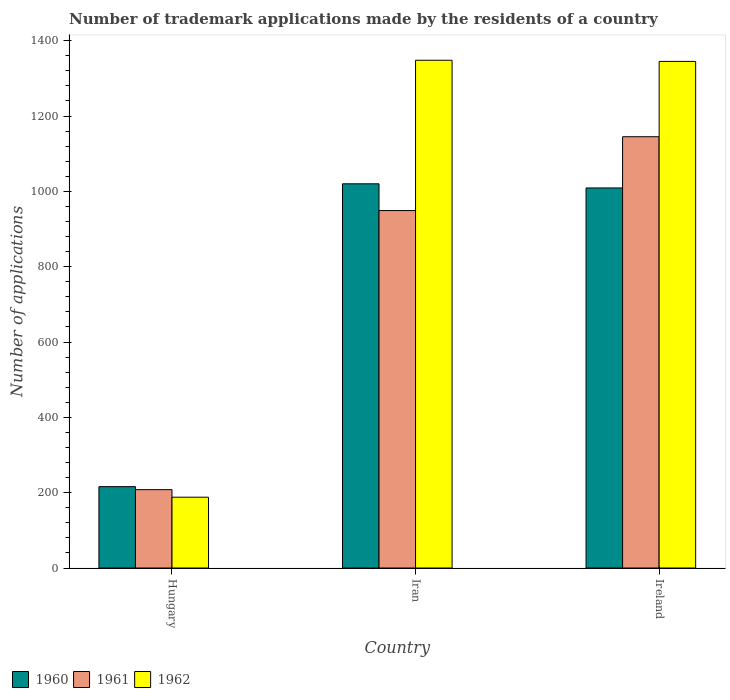How many different coloured bars are there?
Offer a terse response. 3. How many groups of bars are there?
Provide a succinct answer. 3. Are the number of bars on each tick of the X-axis equal?
Give a very brief answer. Yes. How many bars are there on the 1st tick from the left?
Provide a succinct answer. 3. How many bars are there on the 3rd tick from the right?
Provide a short and direct response. 3. What is the label of the 2nd group of bars from the left?
Your answer should be very brief. Iran. What is the number of trademark applications made by the residents in 1961 in Ireland?
Keep it short and to the point. 1145. Across all countries, what is the maximum number of trademark applications made by the residents in 1962?
Make the answer very short. 1348. Across all countries, what is the minimum number of trademark applications made by the residents in 1961?
Make the answer very short. 208. In which country was the number of trademark applications made by the residents in 1961 maximum?
Keep it short and to the point. Ireland. In which country was the number of trademark applications made by the residents in 1961 minimum?
Ensure brevity in your answer.  Hungary. What is the total number of trademark applications made by the residents in 1961 in the graph?
Offer a terse response. 2302. What is the difference between the number of trademark applications made by the residents in 1961 in Iran and that in Ireland?
Provide a short and direct response. -196. What is the difference between the number of trademark applications made by the residents in 1962 in Hungary and the number of trademark applications made by the residents in 1960 in Iran?
Your response must be concise. -832. What is the average number of trademark applications made by the residents in 1962 per country?
Provide a short and direct response. 960.33. In how many countries, is the number of trademark applications made by the residents in 1960 greater than 960?
Ensure brevity in your answer.  2. What is the ratio of the number of trademark applications made by the residents in 1962 in Hungary to that in Ireland?
Your answer should be compact. 0.14. Is the number of trademark applications made by the residents in 1960 in Iran less than that in Ireland?
Offer a very short reply. No. Is the difference between the number of trademark applications made by the residents in 1960 in Iran and Ireland greater than the difference between the number of trademark applications made by the residents in 1961 in Iran and Ireland?
Ensure brevity in your answer.  Yes. What is the difference between the highest and the second highest number of trademark applications made by the residents in 1962?
Offer a very short reply. 1157. What is the difference between the highest and the lowest number of trademark applications made by the residents in 1962?
Your answer should be compact. 1160. In how many countries, is the number of trademark applications made by the residents in 1960 greater than the average number of trademark applications made by the residents in 1960 taken over all countries?
Keep it short and to the point. 2. What does the 2nd bar from the left in Iran represents?
Your answer should be very brief. 1961. How many bars are there?
Your answer should be compact. 9. Are all the bars in the graph horizontal?
Keep it short and to the point. No. How many countries are there in the graph?
Your answer should be compact. 3. What is the difference between two consecutive major ticks on the Y-axis?
Your response must be concise. 200. Are the values on the major ticks of Y-axis written in scientific E-notation?
Your answer should be compact. No. Does the graph contain grids?
Ensure brevity in your answer.  No. Where does the legend appear in the graph?
Your answer should be very brief. Bottom left. How are the legend labels stacked?
Keep it short and to the point. Horizontal. What is the title of the graph?
Offer a terse response. Number of trademark applications made by the residents of a country. What is the label or title of the Y-axis?
Offer a terse response. Number of applications. What is the Number of applications of 1960 in Hungary?
Offer a terse response. 216. What is the Number of applications of 1961 in Hungary?
Your answer should be compact. 208. What is the Number of applications of 1962 in Hungary?
Give a very brief answer. 188. What is the Number of applications in 1960 in Iran?
Give a very brief answer. 1020. What is the Number of applications of 1961 in Iran?
Give a very brief answer. 949. What is the Number of applications in 1962 in Iran?
Make the answer very short. 1348. What is the Number of applications of 1960 in Ireland?
Your answer should be compact. 1009. What is the Number of applications in 1961 in Ireland?
Give a very brief answer. 1145. What is the Number of applications in 1962 in Ireland?
Your answer should be compact. 1345. Across all countries, what is the maximum Number of applications of 1960?
Keep it short and to the point. 1020. Across all countries, what is the maximum Number of applications of 1961?
Provide a short and direct response. 1145. Across all countries, what is the maximum Number of applications in 1962?
Provide a succinct answer. 1348. Across all countries, what is the minimum Number of applications of 1960?
Offer a very short reply. 216. Across all countries, what is the minimum Number of applications in 1961?
Offer a terse response. 208. Across all countries, what is the minimum Number of applications in 1962?
Provide a short and direct response. 188. What is the total Number of applications of 1960 in the graph?
Keep it short and to the point. 2245. What is the total Number of applications of 1961 in the graph?
Keep it short and to the point. 2302. What is the total Number of applications of 1962 in the graph?
Your answer should be compact. 2881. What is the difference between the Number of applications of 1960 in Hungary and that in Iran?
Offer a very short reply. -804. What is the difference between the Number of applications of 1961 in Hungary and that in Iran?
Provide a succinct answer. -741. What is the difference between the Number of applications in 1962 in Hungary and that in Iran?
Keep it short and to the point. -1160. What is the difference between the Number of applications in 1960 in Hungary and that in Ireland?
Your answer should be compact. -793. What is the difference between the Number of applications of 1961 in Hungary and that in Ireland?
Provide a short and direct response. -937. What is the difference between the Number of applications in 1962 in Hungary and that in Ireland?
Offer a very short reply. -1157. What is the difference between the Number of applications in 1961 in Iran and that in Ireland?
Your answer should be very brief. -196. What is the difference between the Number of applications in 1962 in Iran and that in Ireland?
Give a very brief answer. 3. What is the difference between the Number of applications of 1960 in Hungary and the Number of applications of 1961 in Iran?
Ensure brevity in your answer.  -733. What is the difference between the Number of applications of 1960 in Hungary and the Number of applications of 1962 in Iran?
Your answer should be very brief. -1132. What is the difference between the Number of applications in 1961 in Hungary and the Number of applications in 1962 in Iran?
Keep it short and to the point. -1140. What is the difference between the Number of applications of 1960 in Hungary and the Number of applications of 1961 in Ireland?
Your response must be concise. -929. What is the difference between the Number of applications of 1960 in Hungary and the Number of applications of 1962 in Ireland?
Your answer should be very brief. -1129. What is the difference between the Number of applications in 1961 in Hungary and the Number of applications in 1962 in Ireland?
Ensure brevity in your answer.  -1137. What is the difference between the Number of applications of 1960 in Iran and the Number of applications of 1961 in Ireland?
Provide a short and direct response. -125. What is the difference between the Number of applications of 1960 in Iran and the Number of applications of 1962 in Ireland?
Your answer should be very brief. -325. What is the difference between the Number of applications of 1961 in Iran and the Number of applications of 1962 in Ireland?
Keep it short and to the point. -396. What is the average Number of applications in 1960 per country?
Your answer should be very brief. 748.33. What is the average Number of applications of 1961 per country?
Give a very brief answer. 767.33. What is the average Number of applications of 1962 per country?
Offer a very short reply. 960.33. What is the difference between the Number of applications of 1961 and Number of applications of 1962 in Hungary?
Ensure brevity in your answer.  20. What is the difference between the Number of applications in 1960 and Number of applications in 1961 in Iran?
Keep it short and to the point. 71. What is the difference between the Number of applications in 1960 and Number of applications in 1962 in Iran?
Keep it short and to the point. -328. What is the difference between the Number of applications of 1961 and Number of applications of 1962 in Iran?
Keep it short and to the point. -399. What is the difference between the Number of applications of 1960 and Number of applications of 1961 in Ireland?
Provide a succinct answer. -136. What is the difference between the Number of applications in 1960 and Number of applications in 1962 in Ireland?
Ensure brevity in your answer.  -336. What is the difference between the Number of applications of 1961 and Number of applications of 1962 in Ireland?
Provide a succinct answer. -200. What is the ratio of the Number of applications of 1960 in Hungary to that in Iran?
Keep it short and to the point. 0.21. What is the ratio of the Number of applications of 1961 in Hungary to that in Iran?
Give a very brief answer. 0.22. What is the ratio of the Number of applications in 1962 in Hungary to that in Iran?
Your response must be concise. 0.14. What is the ratio of the Number of applications in 1960 in Hungary to that in Ireland?
Offer a terse response. 0.21. What is the ratio of the Number of applications of 1961 in Hungary to that in Ireland?
Give a very brief answer. 0.18. What is the ratio of the Number of applications in 1962 in Hungary to that in Ireland?
Your answer should be very brief. 0.14. What is the ratio of the Number of applications in 1960 in Iran to that in Ireland?
Your response must be concise. 1.01. What is the ratio of the Number of applications in 1961 in Iran to that in Ireland?
Your response must be concise. 0.83. What is the ratio of the Number of applications of 1962 in Iran to that in Ireland?
Offer a terse response. 1. What is the difference between the highest and the second highest Number of applications in 1960?
Keep it short and to the point. 11. What is the difference between the highest and the second highest Number of applications of 1961?
Provide a succinct answer. 196. What is the difference between the highest and the second highest Number of applications of 1962?
Provide a succinct answer. 3. What is the difference between the highest and the lowest Number of applications of 1960?
Your answer should be very brief. 804. What is the difference between the highest and the lowest Number of applications in 1961?
Provide a short and direct response. 937. What is the difference between the highest and the lowest Number of applications of 1962?
Give a very brief answer. 1160. 